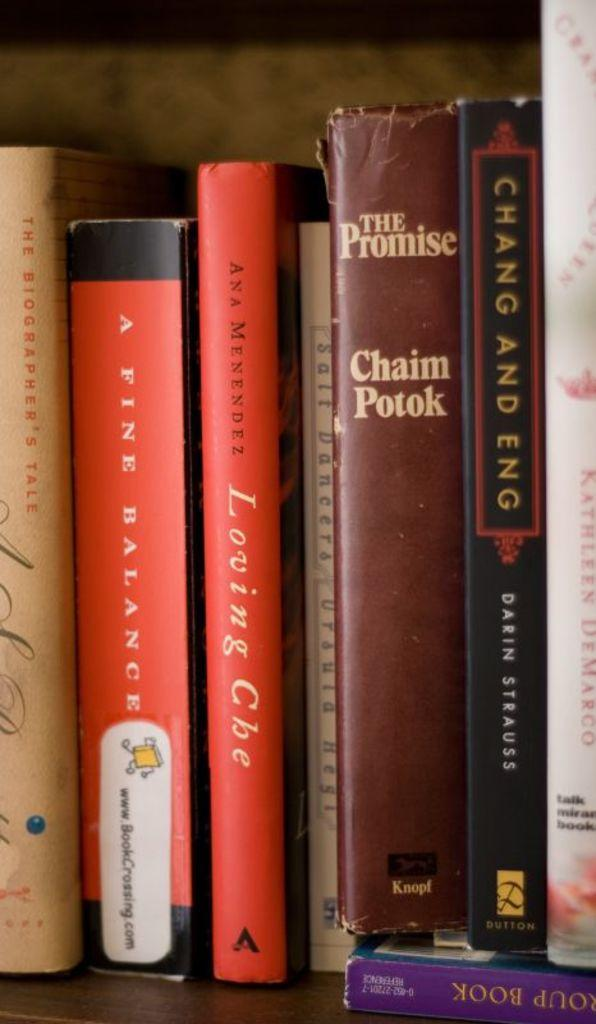<image>
Offer a succinct explanation of the picture presented. A collection of books standing upright, one titled The Promise. 